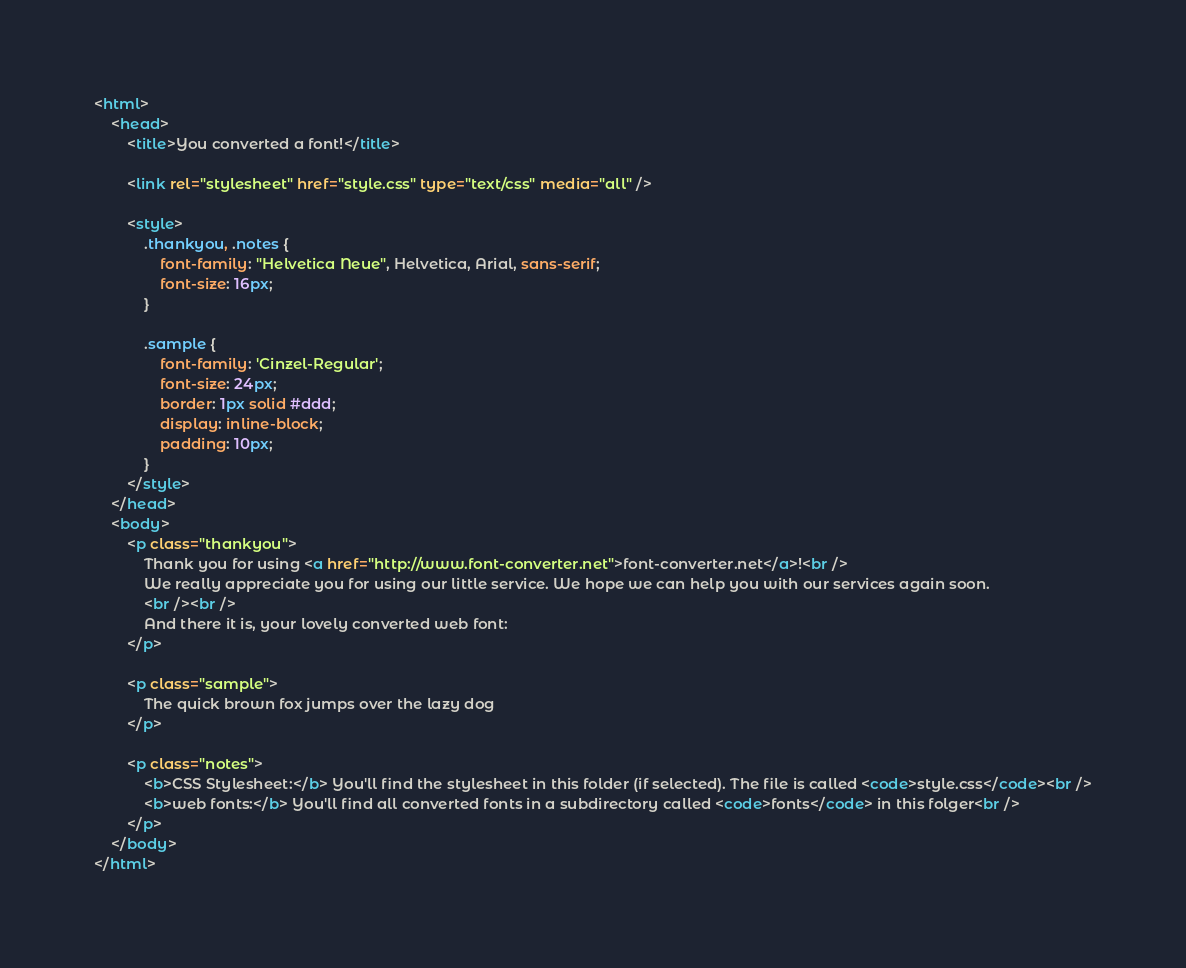Convert code to text. <code><loc_0><loc_0><loc_500><loc_500><_HTML_><html>
    <head>
        <title>You converted a font!</title>
        
        <link rel="stylesheet" href="style.css" type="text/css" media="all" />
        
        <style>
            .thankyou, .notes {
                font-family: "Helvetica Neue", Helvetica, Arial, sans-serif;
                font-size: 16px;
            }

            .sample {
                font-family: 'Cinzel-Regular';
                font-size: 24px;
                border: 1px solid #ddd;
                display: inline-block;
                padding: 10px;
            }
        </style>
    </head>
    <body>
        <p class="thankyou">
            Thank you for using <a href="http://www.font-converter.net">font-converter.net</a>!<br />
            We really appreciate you for using our little service. We hope we can help you with our services again soon.
            <br /><br />
            And there it is, your lovely converted web font:
        </p>

        <p class="sample">
            The quick brown fox jumps over the lazy dog
        </p>

        <p class="notes">
            <b>CSS Stylesheet:</b> You'll find the stylesheet in this folder (if selected). The file is called <code>style.css</code><br />
            <b>web fonts:</b> You'll find all converted fonts in a subdirectory called <code>fonts</code> in this folger<br />
        </p>
    </body>
</html></code> 